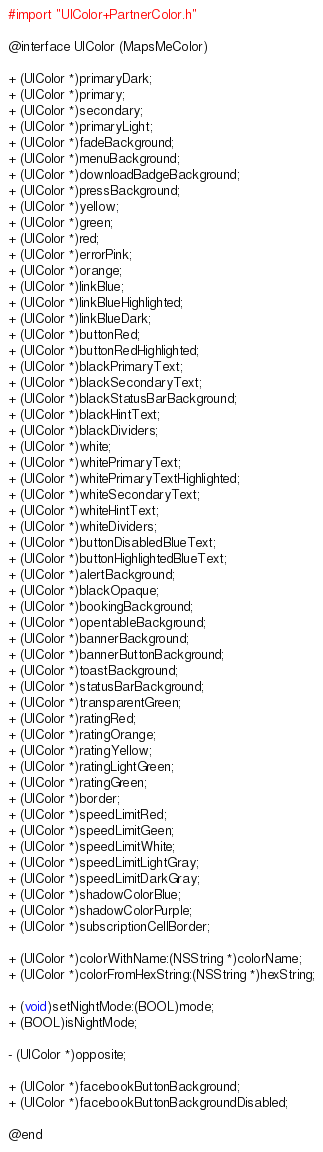Convert code to text. <code><loc_0><loc_0><loc_500><loc_500><_C_>#import "UIColor+PartnerColor.h"

@interface UIColor (MapsMeColor)

+ (UIColor *)primaryDark;
+ (UIColor *)primary;
+ (UIColor *)secondary;
+ (UIColor *)primaryLight;
+ (UIColor *)fadeBackground;
+ (UIColor *)menuBackground;
+ (UIColor *)downloadBadgeBackground;
+ (UIColor *)pressBackground;
+ (UIColor *)yellow;
+ (UIColor *)green;
+ (UIColor *)red;
+ (UIColor *)errorPink;
+ (UIColor *)orange;
+ (UIColor *)linkBlue;
+ (UIColor *)linkBlueHighlighted;
+ (UIColor *)linkBlueDark;
+ (UIColor *)buttonRed;
+ (UIColor *)buttonRedHighlighted;
+ (UIColor *)blackPrimaryText;
+ (UIColor *)blackSecondaryText;
+ (UIColor *)blackStatusBarBackground;
+ (UIColor *)blackHintText;
+ (UIColor *)blackDividers;
+ (UIColor *)white;
+ (UIColor *)whitePrimaryText;
+ (UIColor *)whitePrimaryTextHighlighted;
+ (UIColor *)whiteSecondaryText;
+ (UIColor *)whiteHintText;
+ (UIColor *)whiteDividers;
+ (UIColor *)buttonDisabledBlueText;
+ (UIColor *)buttonHighlightedBlueText;
+ (UIColor *)alertBackground;
+ (UIColor *)blackOpaque;
+ (UIColor *)bookingBackground;
+ (UIColor *)opentableBackground;
+ (UIColor *)bannerBackground;
+ (UIColor *)bannerButtonBackground;
+ (UIColor *)toastBackground;
+ (UIColor *)statusBarBackground;
+ (UIColor *)transparentGreen;
+ (UIColor *)ratingRed;
+ (UIColor *)ratingOrange;
+ (UIColor *)ratingYellow;
+ (UIColor *)ratingLightGreen;
+ (UIColor *)ratingGreen;
+ (UIColor *)border;
+ (UIColor *)speedLimitRed;
+ (UIColor *)speedLimitGeen;
+ (UIColor *)speedLimitWhite;
+ (UIColor *)speedLimitLightGray;
+ (UIColor *)speedLimitDarkGray;
+ (UIColor *)shadowColorBlue;
+ (UIColor *)shadowColorPurple;
+ (UIColor *)subscriptionCellBorder;

+ (UIColor *)colorWithName:(NSString *)colorName;
+ (UIColor *)colorFromHexString:(NSString *)hexString;

+ (void)setNightMode:(BOOL)mode;
+ (BOOL)isNightMode;

- (UIColor *)opposite;

+ (UIColor *)facebookButtonBackground;
+ (UIColor *)facebookButtonBackgroundDisabled;

@end
</code> 